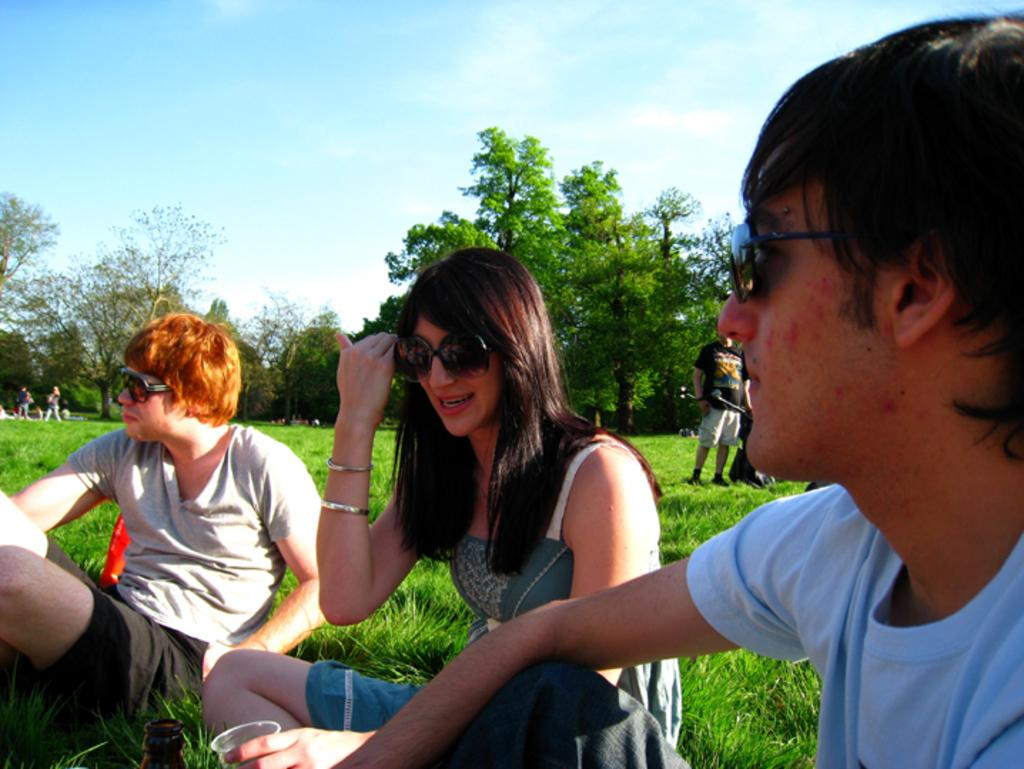How many people are in the image? There are many people in the image. What are some of the people in the image doing? Some people are sitting. What are the people wearing on their faces? The people are wearing goggles. What type of terrain is visible in the image? There is grass on the ground in the image. What can be seen in the background of the image? There are trees and the sky visible in the background of the image. What is the condition of the sky in the image? Clouds are present in the sky. What type of pickle is the dad holding in the image? There is no dad or pickle present in the image. What crime did the person commit to be in jail in the image? There is no jail or person committing a crime in the image. 